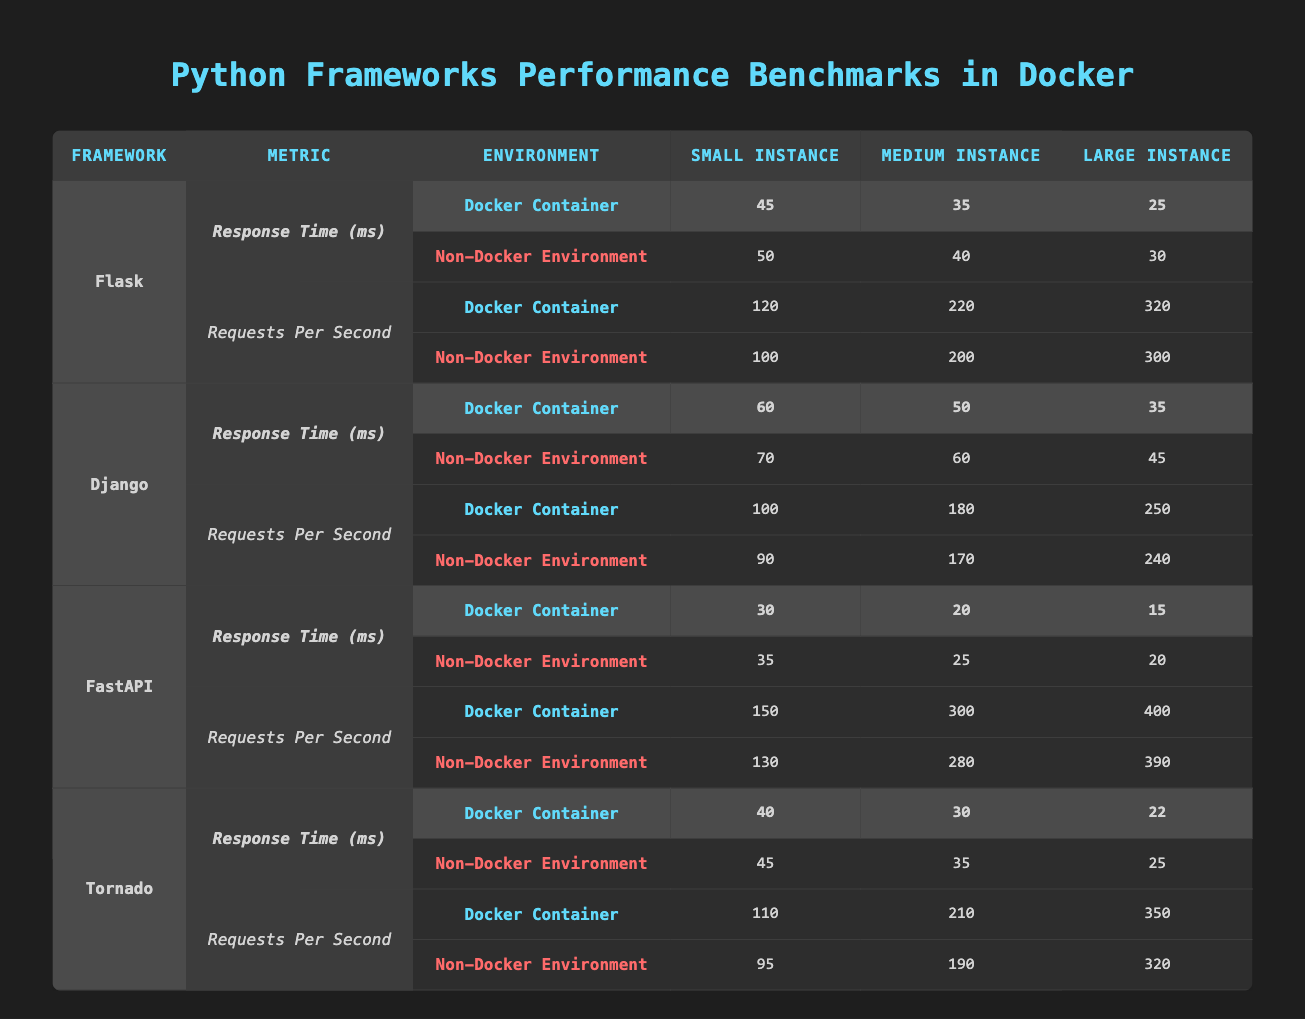What is the response time for Flask in a Docker container with a Large Instance? From the table under the section for Flask, the response time in a Docker container for a Large Instance is listed as 25 ms.
Answer: 25 ms What is the difference in requests per second between Django and Tornado in a Docker container for a Medium Instance? Looking at the Requests Per Second for both frameworks in a Docker container: Django has 180 requests per second and Tornado has 210. The difference is 210 - 180 = 30 requests per second.
Answer: 30 requests per second Is the response time for FastAPI in a Non-Docker environment larger than in a Docker container? The response times for FastAPI are 35 ms (Non-Docker) and 30 ms (Docker). Since 35 ms is greater than 30 ms, the statement is true.
Answer: Yes What is the average response time for Flask in the Non-Docker environment across all instance sizes? The response times for Flask in a Non-Docker environment are 50 ms (Small), 40 ms (Medium), and 30 ms (Large). The sum is 50 + 40 + 30 = 120 ms. The average is 120 ms / 3 = 40 ms.
Answer: 40 ms Are the Requests Per Second for FastAPI in Docker containers higher than those in Non-Docker environments across all instance sizes? For FastAPI in Docker, the values are 150 (Small), 300 (Medium), and 400 (Large). In the Non-Docker environment, the values are 130 (Small), 280 (Medium), and 390 (Large). Since all Docker values are higher, the statement is true.
Answer: Yes What is the response time for Django in a Docker container with a Medium Instance? For Django in a Docker environment, the response time for a Medium Instance is displayed as 50 ms.
Answer: 50 ms By how much does the small instance requests per second in a Non-Docker environment for Tornado exceed that of Flask? Tornado has 95 requests per second (Non-Docker) for the Small Instance, and Flask has 100 requests per second. The difference is 95 - 100 = -5, indicating Tornado is 5 requests per second less.
Answer: 5 requests per second less What is the highest response time recorded across all frameworks in a Docker container? Comparing the response times in the Docker container: Flask (45 ms), Django (60 ms), FastAPI (30 ms), and Tornado (40 ms). The highest response time is from Django at 60 ms.
Answer: 60 ms How many instances in the Docker environment have a response time under 40 ms? Looking at each framework's response times in Docker: Flask (45 ms), Django (60 ms), FastAPI (30 ms), and Tornado (40 ms). Only FastAPI has a response time under 40 ms, so there is 1 instance.
Answer: 1 instance 